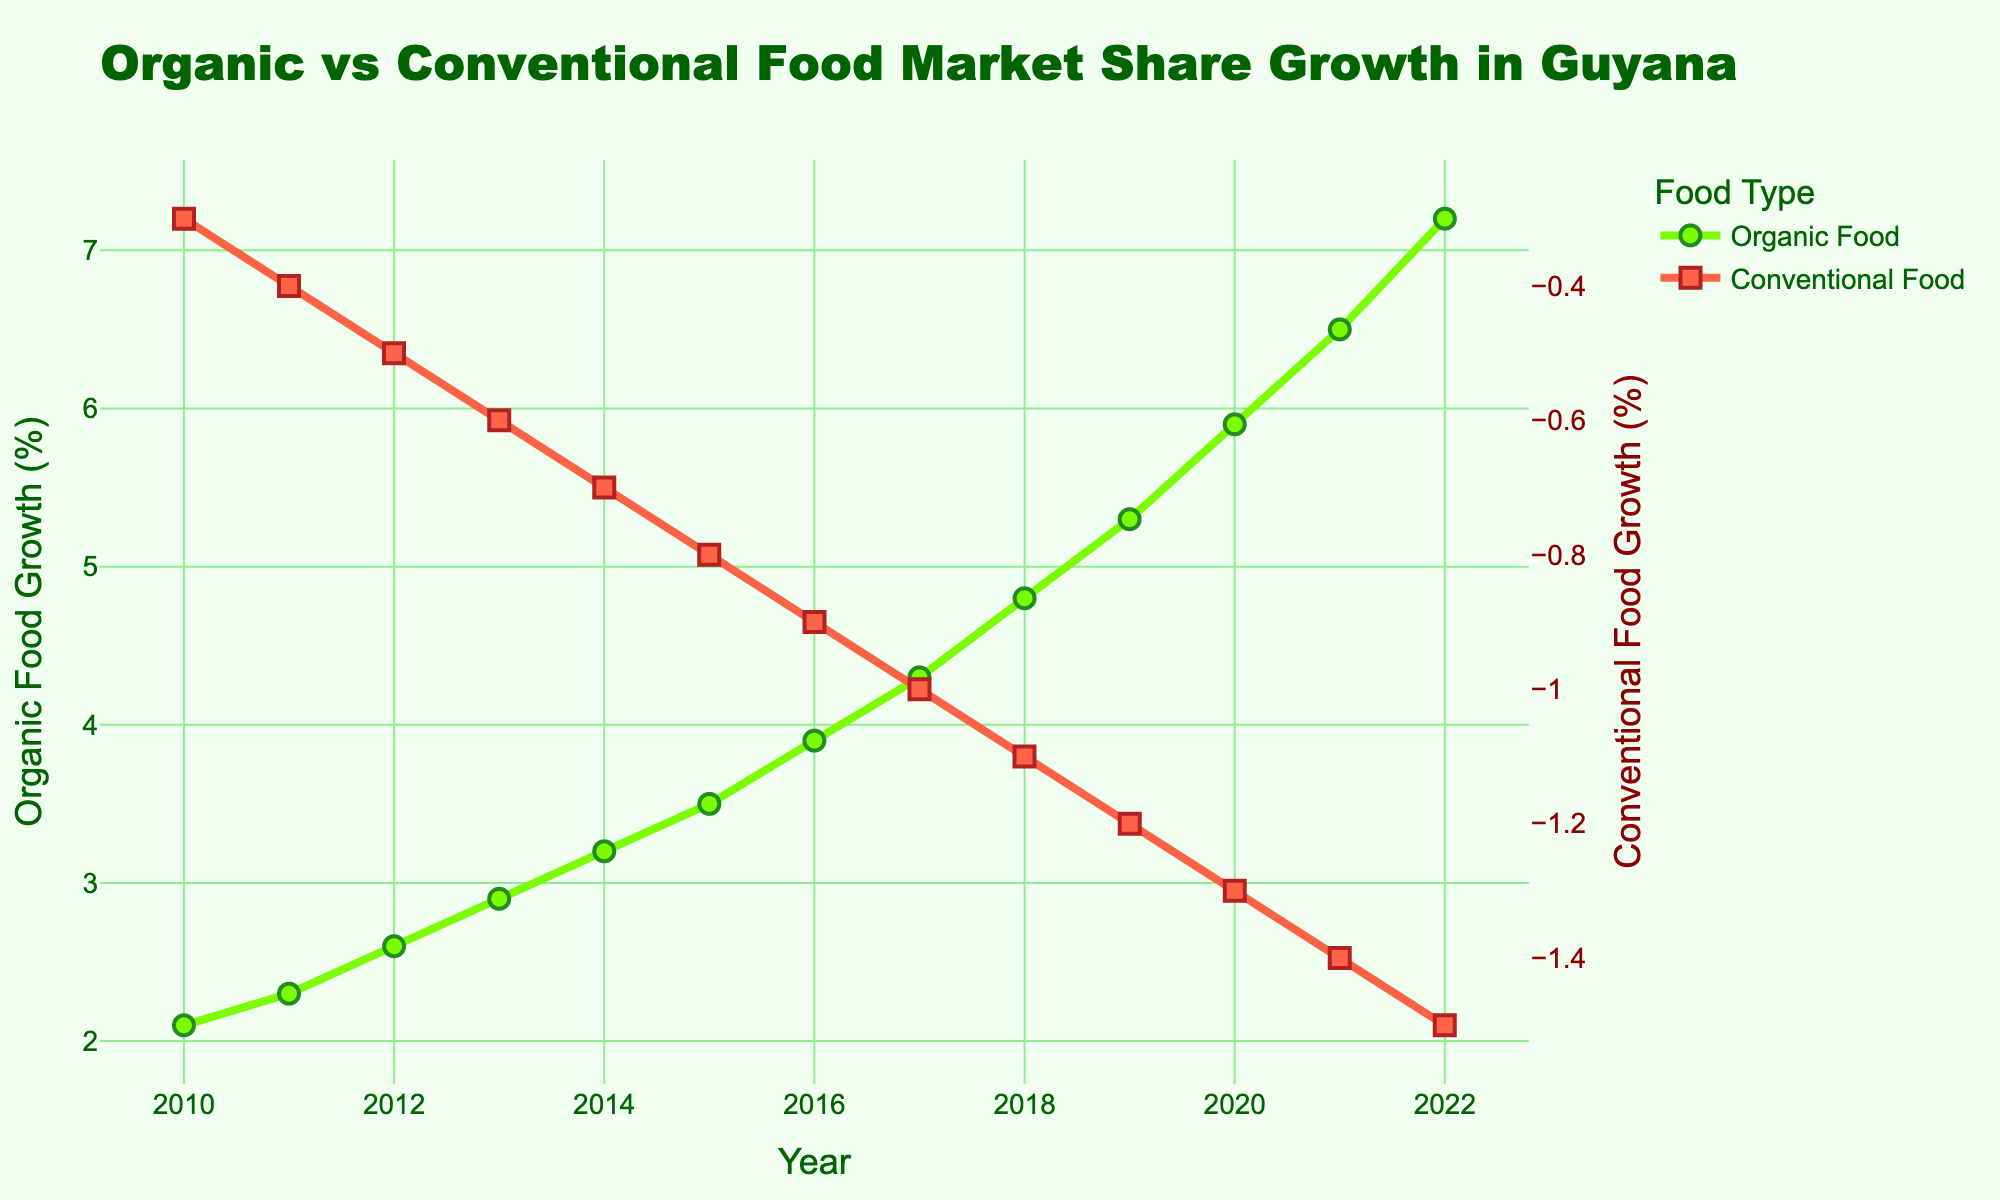what is the growth rate difference between organic food and conventional food in 2016? The growth rate for organic food in 2016 is 3.9%, and for conventional food is -0.9%. The difference is 3.9% - (-0.9%) = 3.9% + 0.9%. Therefore, the difference is 4.8%.
Answer: 4.8% which year had the highest growth rate for organic food? By observing the chart, the year with the highest point for organic food growth is 2022, where the growth rate is 7.2%.
Answer: 2022 how do the growth rates of organic and conventional food compare in 2010? In 2010, the growth rate for organic food is 2.1%, while for conventional food it is -0.3%. Organic food shows positive growth, while conventional food shows a negative growth rate.
Answer: Organic food: 2.1%, Conventional food: -0.3% what is the average growth rate of organic food over the period from 2010 to 2022? Sum the growth rates for organic food from 2010 to 2022 and divide by the number of years. (2.1 + 2.3 + 2.6 + 2.9 + 3.2 + 3.5 + 3.9 + 4.3 + 4.8 + 5.3 + 5.9 + 6.5 + 7.2) / 13 = 54.5 / 13 = 4.19% (approx).
Answer: 4.19% between which two consecutive years did organic food growth increase the most? By observing the steepness of the green line, the largest increase appears between 2021 and 2022. The growth rate in 2021 is 6.5% and in 2022 is 7.2%, so the increase is 7.2% - 6.5% = 0.7%.
Answer: 2021 to 2022 what visual differences can be observed between the representations of organic and conventional food growth? Organic food growth is represented by a green line with circular markers, while conventional food growth is shown using a red line with square markers.
Answer: Green line with circles (organic), red line with squares (conventional) how does the trend of conventional food growth compare to that of organic food over the period from 2010 to 2022? The trend for organic food growth consistently increases each year, while the trend for conventional food growth consistently decreases each year.
Answer: Organic: increasing, Conventional: decreasing 